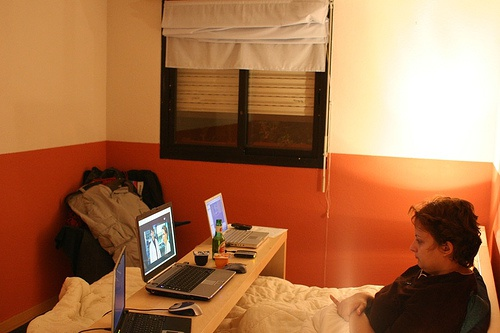Describe the objects in this image and their specific colors. I can see people in tan, black, maroon, and brown tones, bed in tan, orange, and red tones, laptop in tan, black, brown, white, and maroon tones, laptop in tan, black, purple, maroon, and brown tones, and laptop in tan, violet, brown, and lavender tones in this image. 